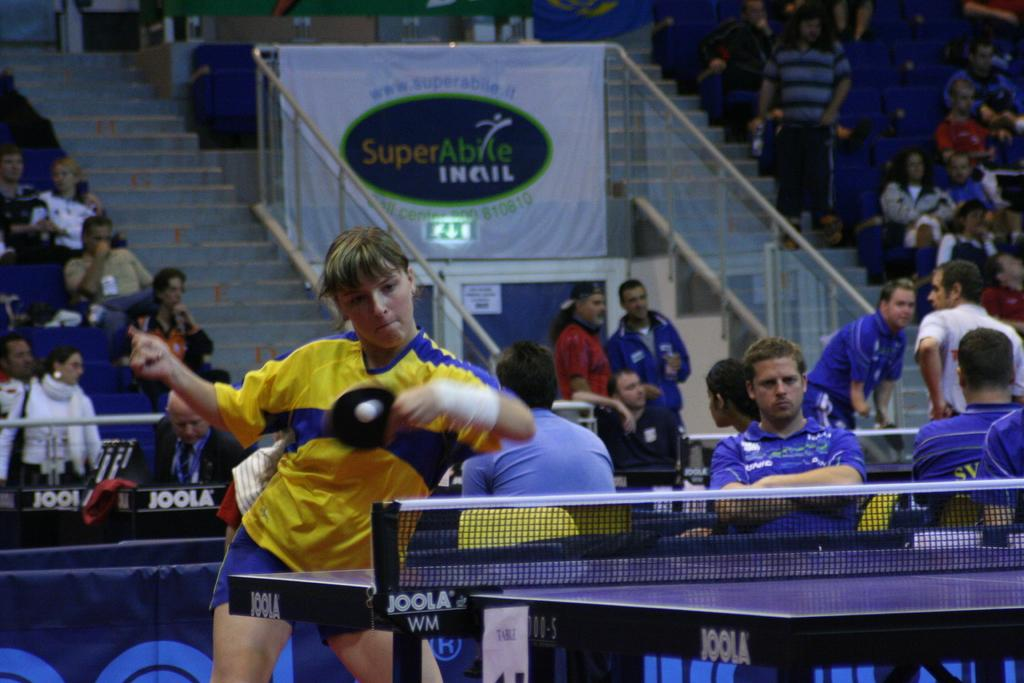What activity is the woman engaged in within the image? The woman is playing table tennis in the image. What can be seen in the background of the image? There are people sitting on the steps in the background of the image. Where was the image taken? The image was taken inside a stadium. What effect does the table tennis game have on the cub in the image? There is no cub present in the image, so it is not possible to determine any effect on a cub. 